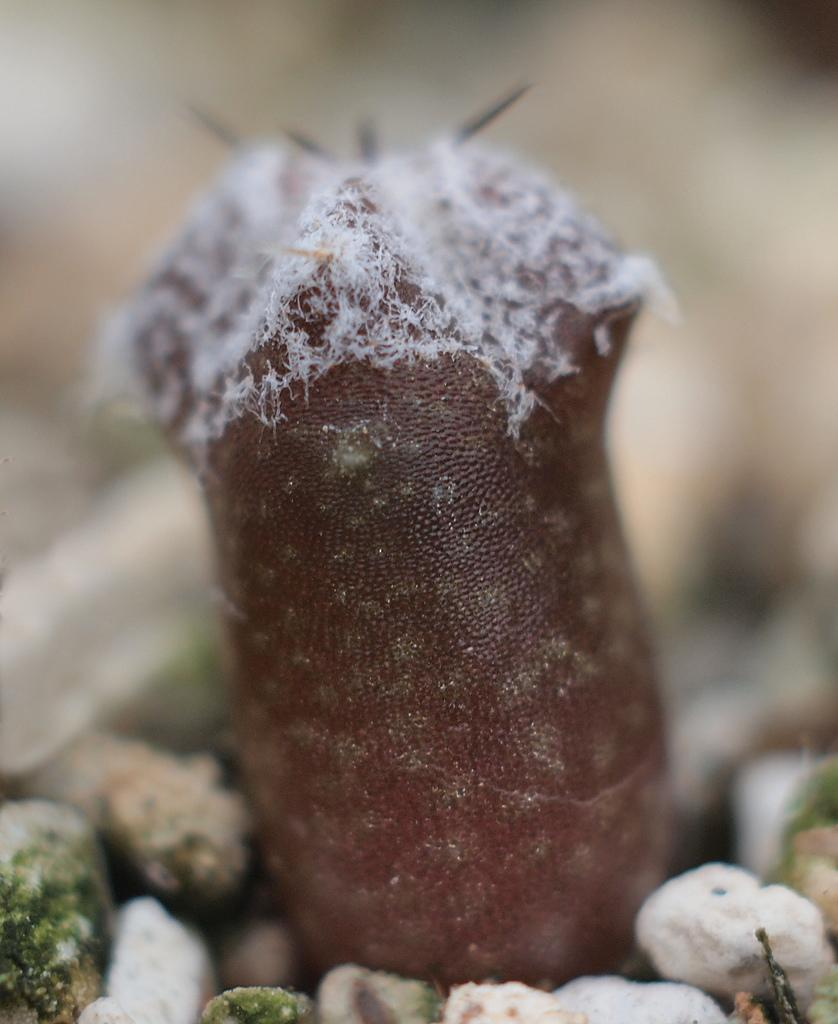What type of plant is in the picture? There is a cactus in the picture. Can you describe the background of the image? The background of the image is blurred. What type of protest is happening in the background of the image? There is no protest visible in the image; the background is blurred. How many bubbles can be seen floating around the cactus in the image? There are no bubbles present in the image; it features a cactus and a blurred background. 